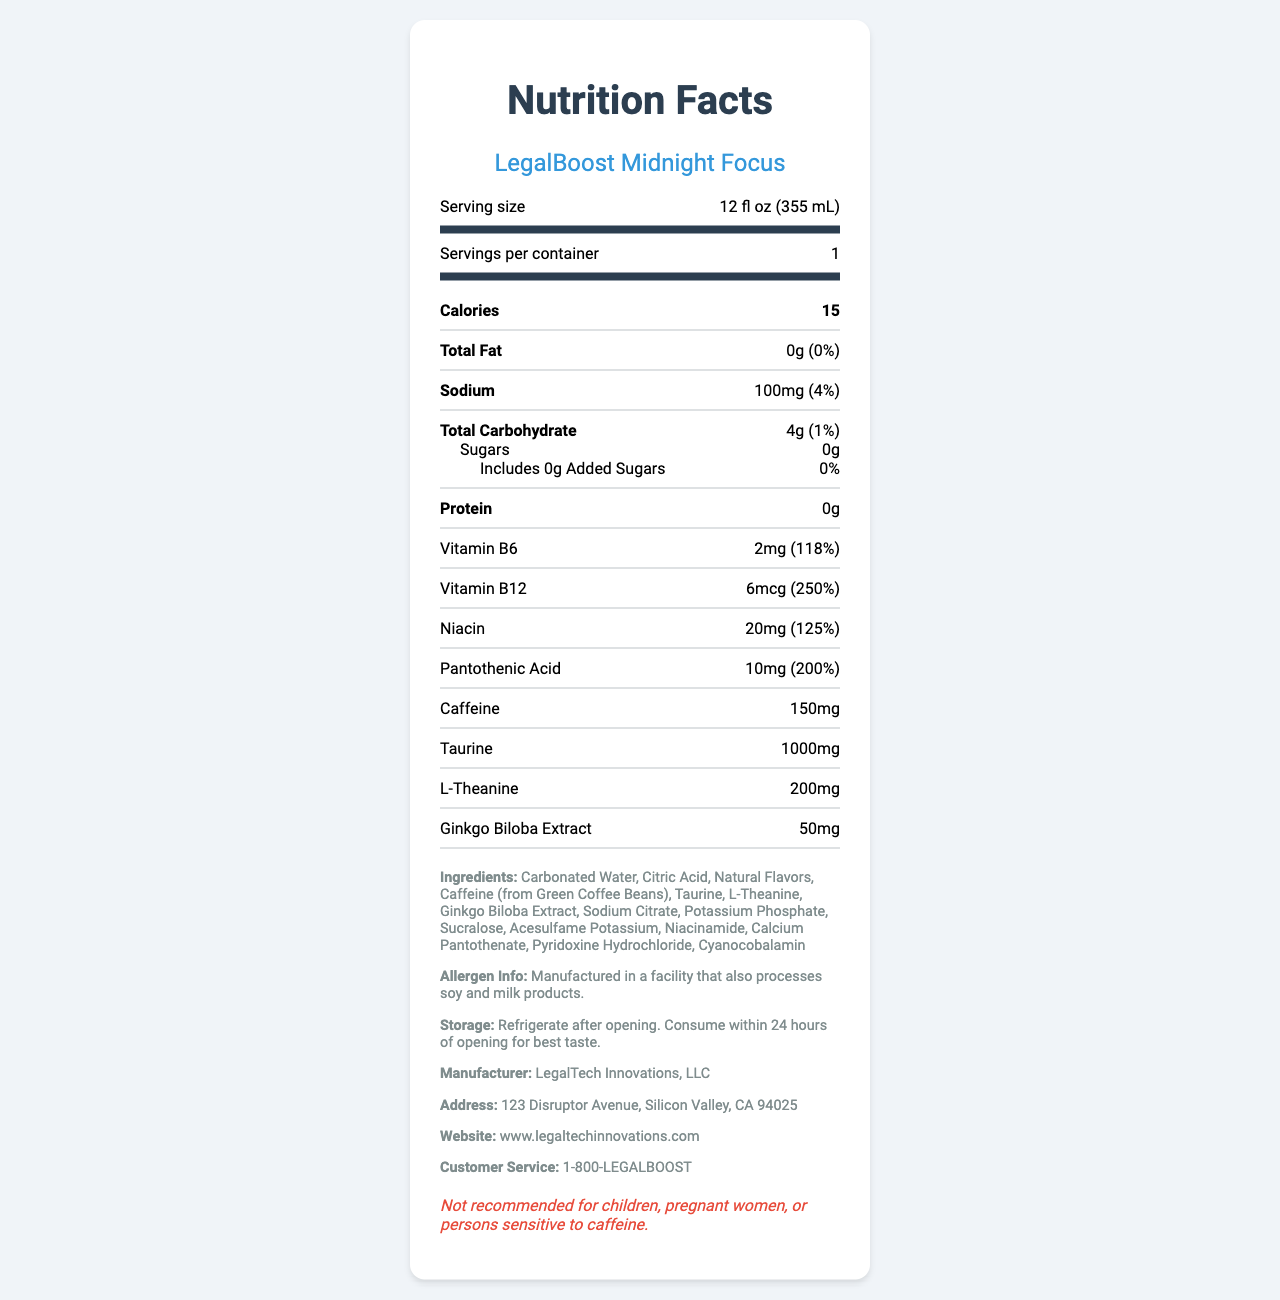what is the serving size of LegalBoost Midnight Focus? The serving size is mentioned under the "Serving size" label near the top of the document.
Answer: 12 fl oz (355 mL) how many calories are in one serving of LegalBoost Midnight Focus? The number of calories is listed prominently under the Calories section in the document.
Answer: 15 how much sodium does LegalBoost Midnight Focus contain? The sodium content is listed as "100mg" with a daily value percentage of "4%" in the document.
Answer: 100mg what is the total carbohydrate amount in LegalBoost Midnight Focus? The total carbohydrate content is listed as "4g" with a daily value percentage of "1%" in the document.
Answer: 4g does LegalBoost Midnight Focus contain any protein? The protein amount is listed as "0g" in the document.
Answer: No What is the daily value percentage for Vitamin B6 in LegalBoost Midnight Focus? The daily value percentage for Vitamin B6 is listed as "118%" in the document.
Answer: 118% Which ingredient is found in the greatest quantity by weight in LegalBoost Midnight Focus? A. Sucralose B. Carbonated Water C. Taurine D. Sodium Citrate The ingredients are listed in descending order by weight, and Carbonated Water is listed first.
Answer: B. Carbonated Water Which of the following vitamins has the highest daily value percentage in LegalBoost Midnight Focus? I. Vitamin B6 II. Vitamin B12 III. Niacin IV. Pantothenic Acid Vitamin B12 has a daily value percentage of 250%, which is higher than the others listed: Vitamin B6 (118%), Niacin (125%), and Pantothenic Acid (200%).
Answer: II. Vitamin B12 Is there any added sugar in LegalBoost Midnight Focus? The document states "Includes 0g Added Sugars" with a daily value of "0%".
Answer: No Should children consume LegalBoost Midnight Focus? The disclaimer states "Not recommended for children, pregnant women, or persons sensitive to caffeine."
Answer: No summarize the main information presented in the document. This explanation covers the key nutritional information, vitamin content, additional ingredients, storage, allergen details, and important disclaimers.
Answer: The document provides the nutrition facts for LegalBoost Midnight Focus, a low-calorie energy drink designed for late-night work sessions. It specifies the serving size as 12 fl oz, with one serving per container. The drink contains 15 calories, 100mg of sodium, and 4g of total carbohydrates, including 0g of sugars and added sugars. It is enriched with vitamins like B6, B12, Niacin, and Pantothenic Acid, all with high daily value percentages. The drink contains significant amounts of caffeine, taurine, L-theanine, and ginkgo biloba extract. The ingredients list contains other details about the allergen information, storage instructions, and manufacturer details. There are also disclaimers advising against consumption by children and other sensitive groups. What is the caffeine content of LegalBoost Midnight Focus? The caffeine amount is listed as "150mg" in the document.
Answer: 150mg What are the first three ingredients listed for LegalBoost Midnight Focus? The ingredients are listed in descending order by weight, and the first three are Carbonated Water, Citric Acid, and Natural Flavors.
Answer: Carbonated Water, Citric Acid, Natural Flavors Does the document provide information about any potential allergens? The document states "Manufactured in a facility that also processes soy and milk products."
Answer: Yes How should LegalBoost Midnight Focus be stored after opening? The storage instructions are given in the document.
Answer: Refrigerate after opening. Consume within 24 hours for best taste. Which company manufactures LegalBoost Midnight Focus? The manufacturer is listed as LegalTech Innovations, LLC in the document.
Answer: LegalTech Innovations, LLC Does LegalBoost Midnight Focus contain any natural flavors? The ingredient list includes "Natural Flavors."
Answer: Yes Who is the target audience for LegalBoost Midnight Focus based on the provided information? The disclaimer in the document explicitly states who should avoid the product, indirectly suggesting its intended audience.
Answer: Not recommended for children, pregnant women, or persons sensitive to caffeine Which vitamin in LegalBoost Midnight Focus provides more than 200% of the daily value? A. Vitamin B6 B. Vitamin B12 C. Niacin D. Vitamin C Vitamin B12 provides 250% of the daily value as stated in the document.
Answer: B. Vitamin B12 How much taurine does LegalBoost Midnight Focus contain? The taurine content is listed as "1000mg" in the document.
Answer: 1000mg What is the exact address of the manufacturer of LegalBoost Midnight Focus? The manufacturer's address is given in the document.
Answer: 123 Disruptor Avenue, Silicon Valley, CA 94025 what is the specific amount of pantothenic acid in LegalBoost Midnight Focus? The document lists pantothenic acid as "10mg" with a daily value of "200%".
Answer: 10mg what are the recommended daily percentages for sodium and carbohydrates in LegalBoost Midnight Focus? The document lists sodium at 4% daily value and carbohydrates at 1% daily value.
Answer: Sodium: 4%, Carbohydrates: 1% 